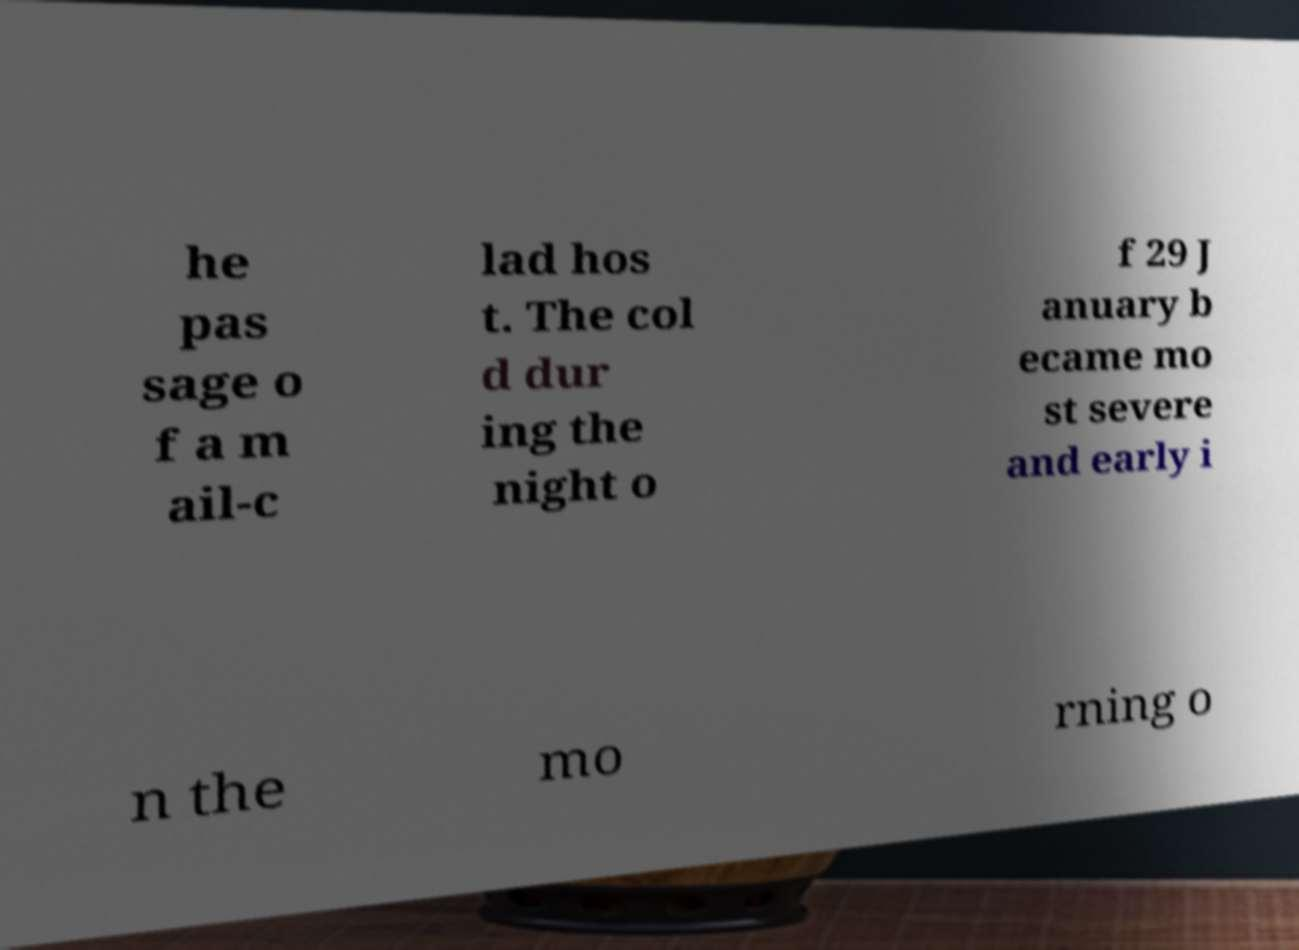Please read and relay the text visible in this image. What does it say? he pas sage o f a m ail-c lad hos t. The col d dur ing the night o f 29 J anuary b ecame mo st severe and early i n the mo rning o 